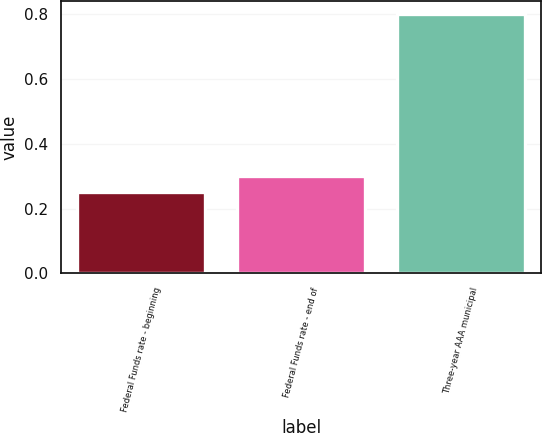<chart> <loc_0><loc_0><loc_500><loc_500><bar_chart><fcel>Federal Funds rate - beginning<fcel>Federal Funds rate - end of<fcel>Three-year AAA municipal<nl><fcel>0.25<fcel>0.3<fcel>0.8<nl></chart> 